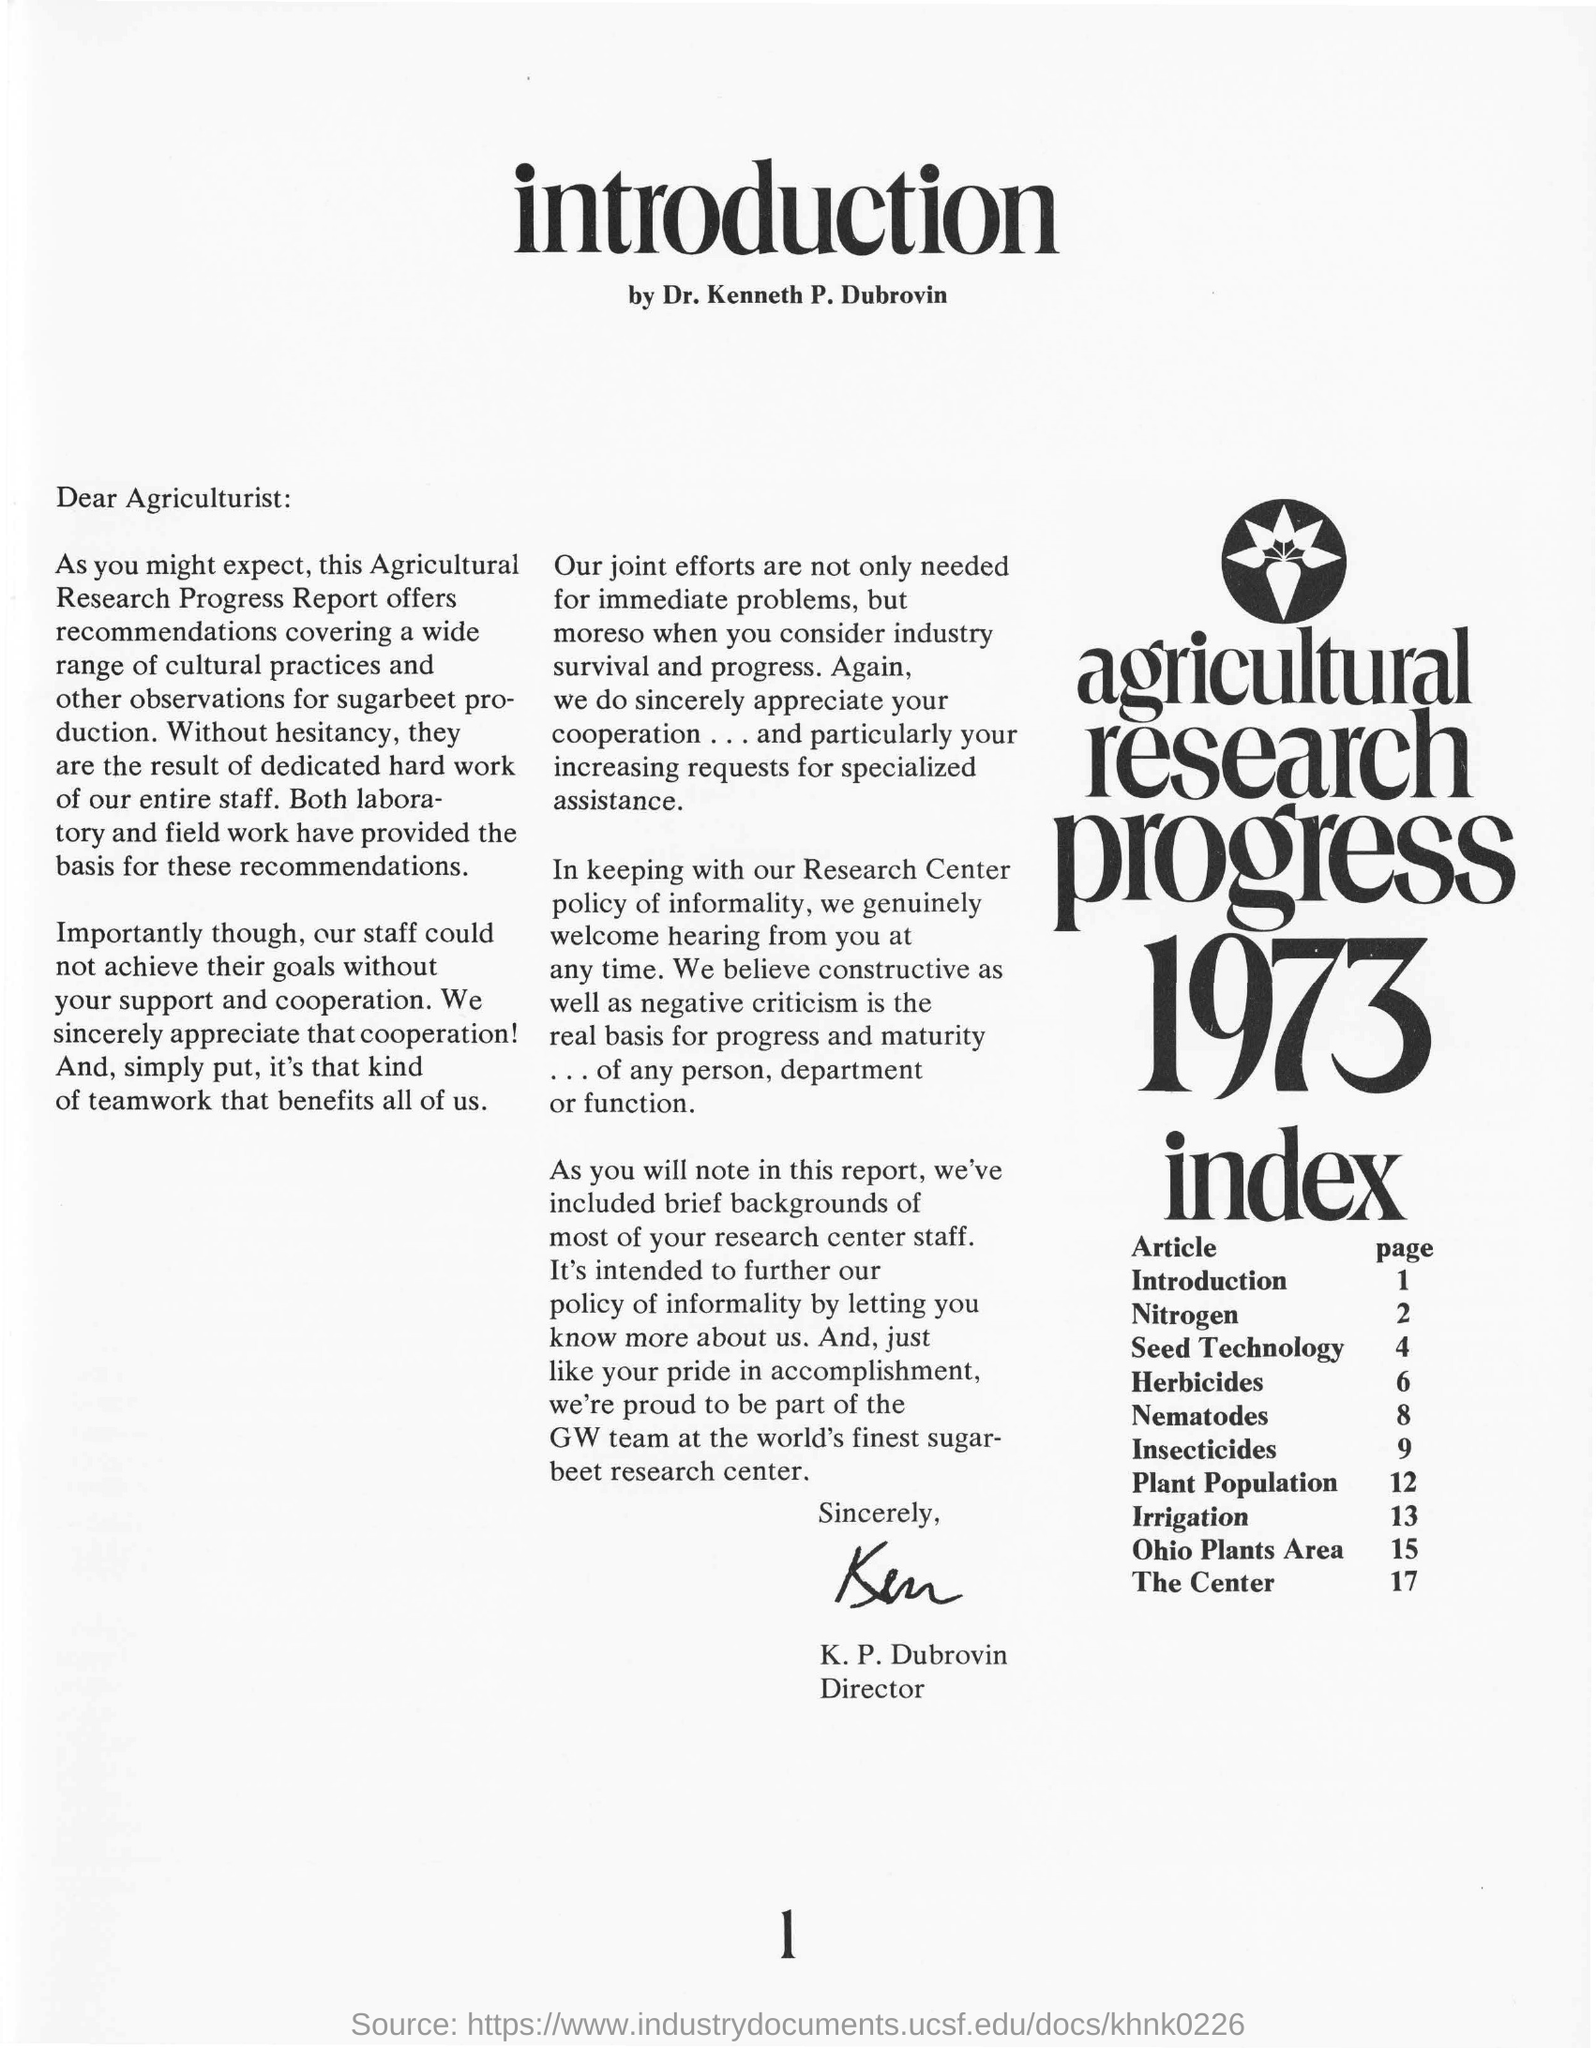What is name of the topic located in page number 12?
Ensure brevity in your answer.  Plant population. To whom is this document addressed?
Make the answer very short. Agriculturist. Who wrote this piece?
Provide a short and direct response. Dr. Kenneth P. Dubrovin. Which page of this report discusses Irrigation?
Offer a terse response. 13. 